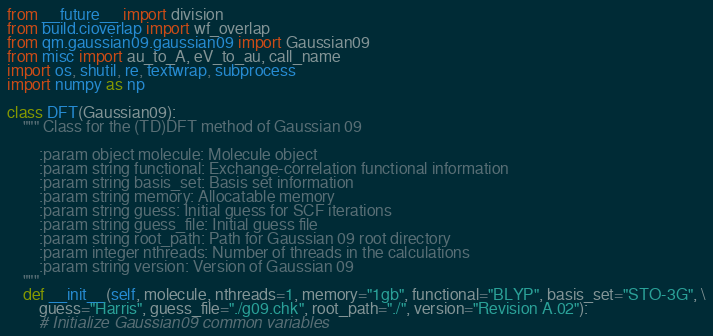Convert code to text. <code><loc_0><loc_0><loc_500><loc_500><_Python_>from __future__ import division
from build.cioverlap import wf_overlap 
from qm.gaussian09.gaussian09 import Gaussian09
from misc import au_to_A, eV_to_au, call_name
import os, shutil, re, textwrap, subprocess
import numpy as np

class DFT(Gaussian09):
    """ Class for the (TD)DFT method of Gaussian 09

        :param object molecule: Molecule object
        :param string functional: Exchange-correlation functional information
        :param string basis_set: Basis set information
        :param string memory: Allocatable memory
        :param string guess: Initial guess for SCF iterations
        :param string guess_file: Initial guess file
        :param string root_path: Path for Gaussian 09 root directory
        :param integer nthreads: Number of threads in the calculations
        :param string version: Version of Gaussian 09
    """
    def __init__(self, molecule, nthreads=1, memory="1gb", functional="BLYP", basis_set="STO-3G", \
        guess="Harris", guess_file="./g09.chk", root_path="./", version="Revision A.02"):
        # Initialize Gaussian09 common variables</code> 